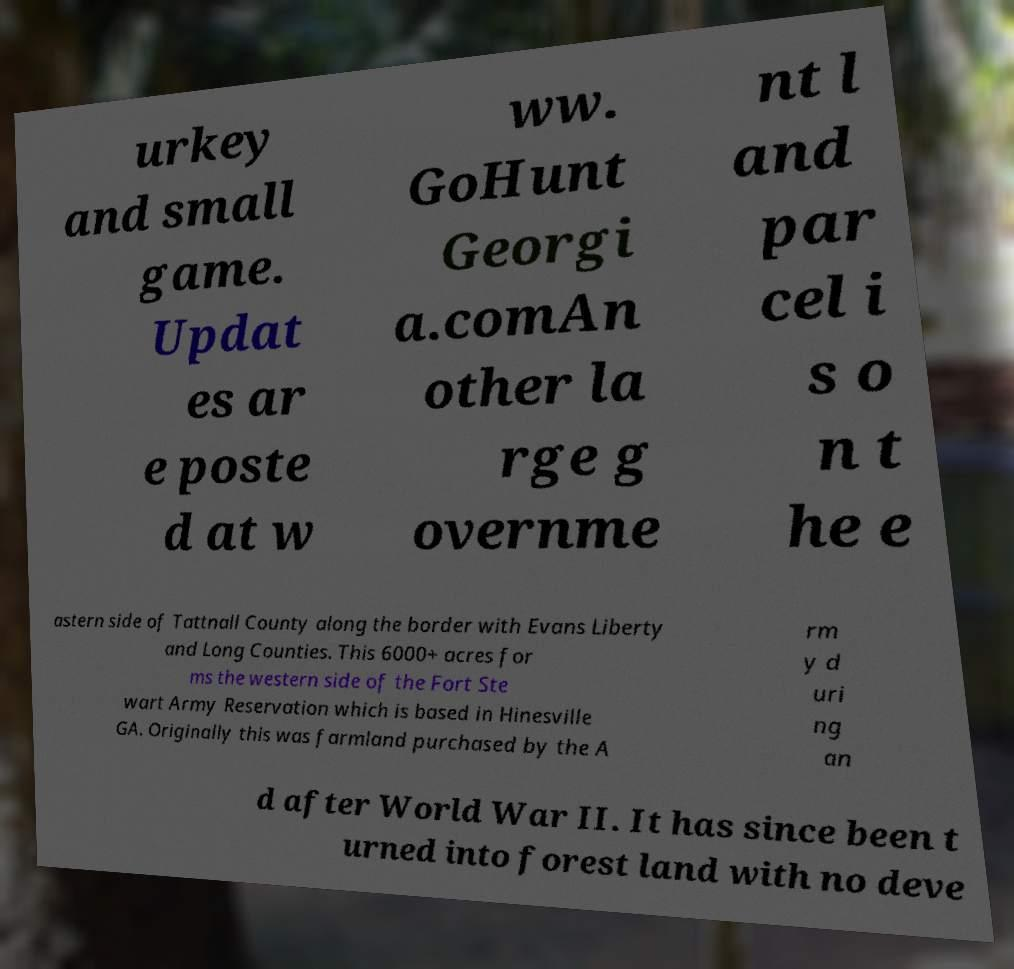Could you assist in decoding the text presented in this image and type it out clearly? urkey and small game. Updat es ar e poste d at w ww. GoHunt Georgi a.comAn other la rge g overnme nt l and par cel i s o n t he e astern side of Tattnall County along the border with Evans Liberty and Long Counties. This 6000+ acres for ms the western side of the Fort Ste wart Army Reservation which is based in Hinesville GA. Originally this was farmland purchased by the A rm y d uri ng an d after World War II. It has since been t urned into forest land with no deve 